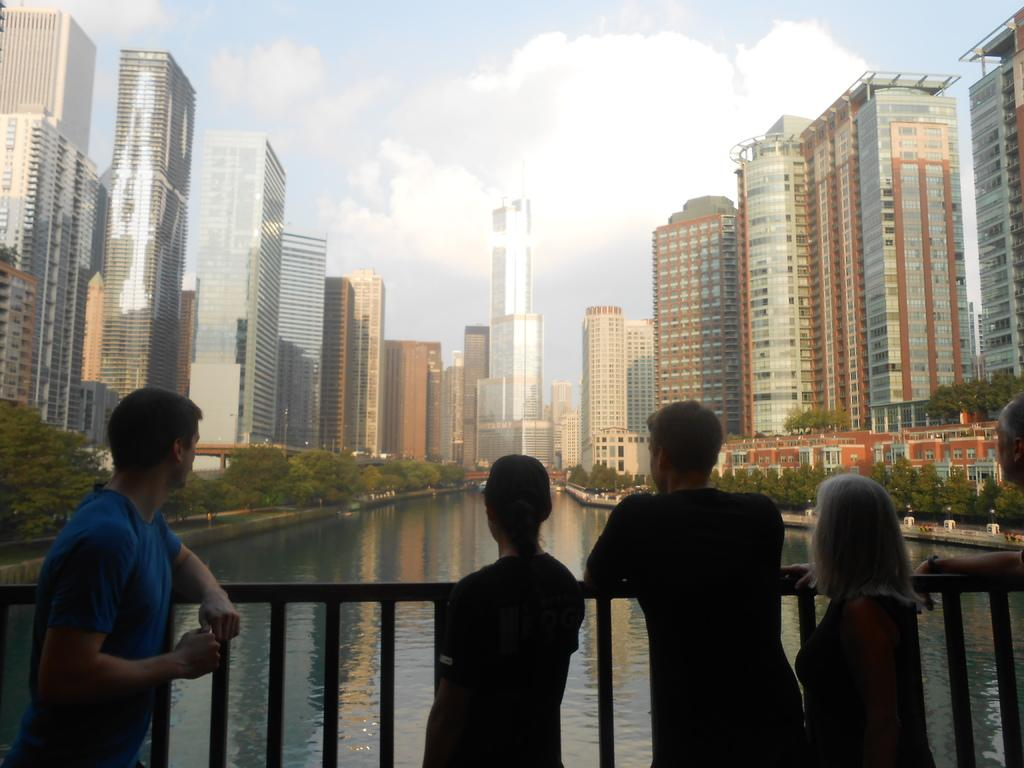What is located in the front of the image? There are people in the front of the image, and there is a railing as well. What can be seen in the background of the image? In the background of the image, there are buildings, trees, water, a bridge, and the sky is cloudy. Can you describe the objects in the background of the image? There are objects in the background of the image, but their specific nature is not mentioned in the facts. What historical event is being commemorated in the image? There is no information about any historical event in the image or the provided facts. How does the cub interact with the objects in the background of the image? There is no mention of a cub in the image or the provided facts. 